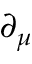<formula> <loc_0><loc_0><loc_500><loc_500>\partial _ { \mu }</formula> 